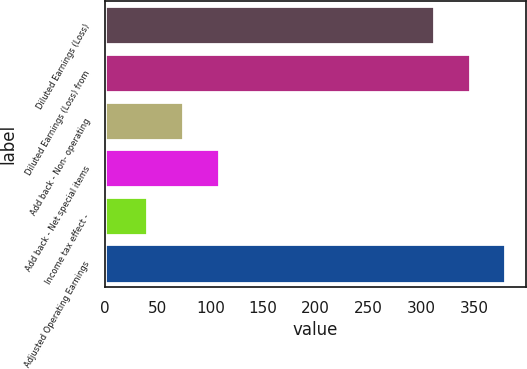<chart> <loc_0><loc_0><loc_500><loc_500><bar_chart><fcel>Diluted Earnings (Loss)<fcel>Diluted Earnings (Loss) from<fcel>Add back - Non- operating<fcel>Add back - Net special items<fcel>Income tax effect -<fcel>Adjusted Operating Earnings<nl><fcel>312<fcel>346<fcel>74<fcel>108<fcel>40<fcel>380<nl></chart> 